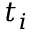Convert formula to latex. <formula><loc_0><loc_0><loc_500><loc_500>t _ { i }</formula> 